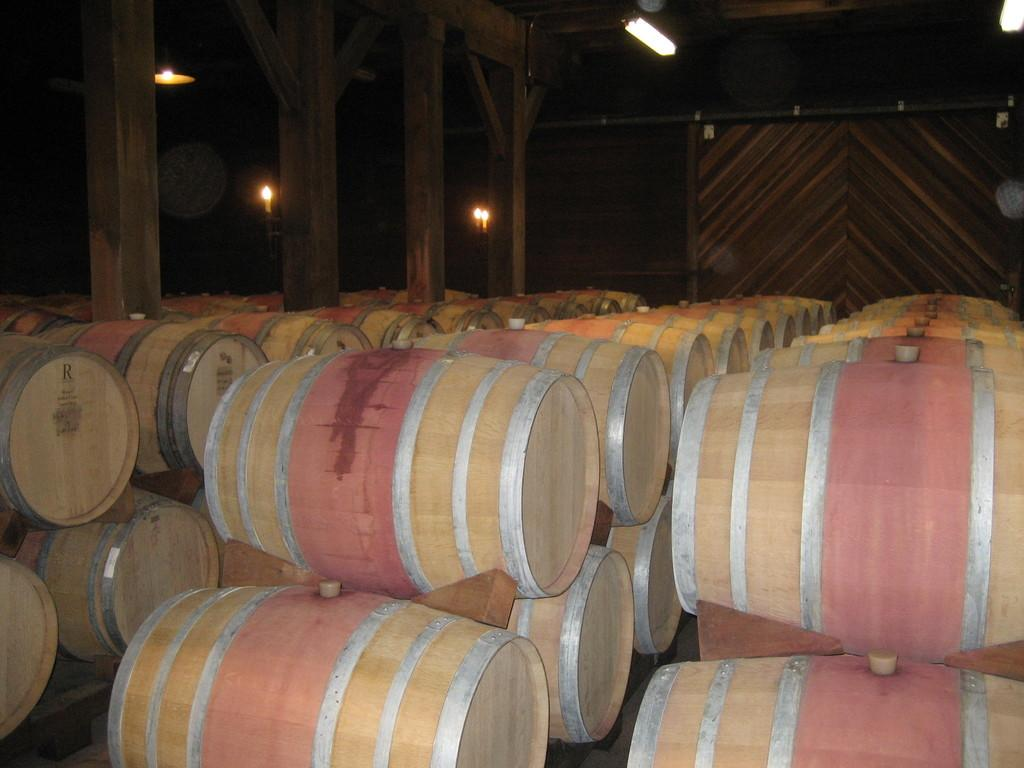What structures can be seen at the top of the image? There are pillars, electric lights, and walls at the top of the image. What objects are arranged in rows at the bottom of the image? Barrels are arranged in rows at the bottom of the image. What type of advertisement can be seen on the walls at the top of the image? There is no advertisement present on the walls in the image; only pillars, electric lights, and walls are visible. What government agency is responsible for the barrels arranged in rows at the bottom of the image? There is no indication of a government agency or involvement in the image; it only shows barrels arranged in rows. 